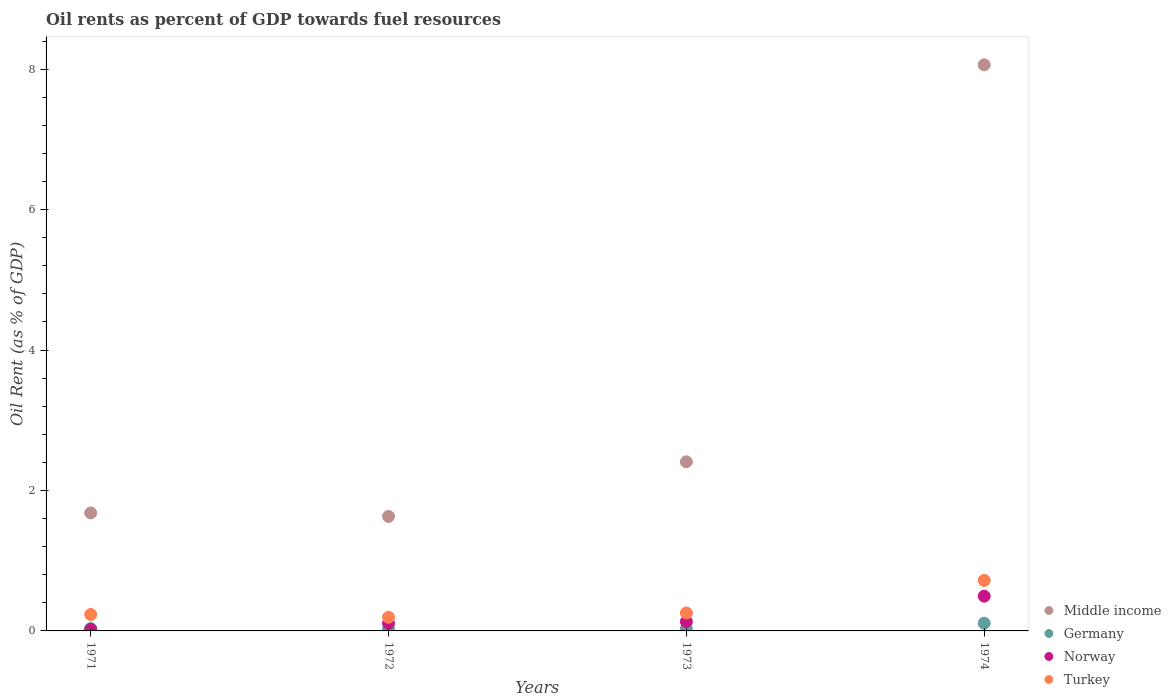What is the oil rent in Germany in 1972?
Offer a very short reply. 0.03. Across all years, what is the maximum oil rent in Germany?
Your answer should be compact. 0.11. Across all years, what is the minimum oil rent in Germany?
Your answer should be compact. 0.03. In which year was the oil rent in Germany maximum?
Give a very brief answer. 1974. In which year was the oil rent in Middle income minimum?
Your response must be concise. 1972. What is the total oil rent in Middle income in the graph?
Ensure brevity in your answer.  13.78. What is the difference between the oil rent in Turkey in 1971 and that in 1974?
Keep it short and to the point. -0.48. What is the difference between the oil rent in Germany in 1973 and the oil rent in Middle income in 1971?
Your answer should be compact. -1.65. What is the average oil rent in Germany per year?
Provide a succinct answer. 0.05. In the year 1973, what is the difference between the oil rent in Norway and oil rent in Turkey?
Your response must be concise. -0.12. What is the ratio of the oil rent in Germany in 1971 to that in 1974?
Your answer should be very brief. 0.31. Is the oil rent in Germany in 1971 less than that in 1973?
Offer a terse response. No. Is the difference between the oil rent in Norway in 1971 and 1973 greater than the difference between the oil rent in Turkey in 1971 and 1973?
Your answer should be compact. No. What is the difference between the highest and the second highest oil rent in Norway?
Make the answer very short. 0.36. What is the difference between the highest and the lowest oil rent in Middle income?
Keep it short and to the point. 6.43. In how many years, is the oil rent in Middle income greater than the average oil rent in Middle income taken over all years?
Keep it short and to the point. 1. Is the sum of the oil rent in Norway in 1972 and 1974 greater than the maximum oil rent in Germany across all years?
Your response must be concise. Yes. Is it the case that in every year, the sum of the oil rent in Germany and oil rent in Norway  is greater than the sum of oil rent in Turkey and oil rent in Middle income?
Your answer should be compact. No. Is it the case that in every year, the sum of the oil rent in Turkey and oil rent in Norway  is greater than the oil rent in Middle income?
Your answer should be very brief. No. How many years are there in the graph?
Your answer should be very brief. 4. Where does the legend appear in the graph?
Offer a terse response. Bottom right. How are the legend labels stacked?
Your response must be concise. Vertical. What is the title of the graph?
Give a very brief answer. Oil rents as percent of GDP towards fuel resources. Does "St. Vincent and the Grenadines" appear as one of the legend labels in the graph?
Provide a short and direct response. No. What is the label or title of the X-axis?
Your answer should be compact. Years. What is the label or title of the Y-axis?
Provide a short and direct response. Oil Rent (as % of GDP). What is the Oil Rent (as % of GDP) in Middle income in 1971?
Give a very brief answer. 1.68. What is the Oil Rent (as % of GDP) in Germany in 1971?
Your response must be concise. 0.03. What is the Oil Rent (as % of GDP) in Norway in 1971?
Make the answer very short. 0.02. What is the Oil Rent (as % of GDP) of Turkey in 1971?
Give a very brief answer. 0.23. What is the Oil Rent (as % of GDP) of Middle income in 1972?
Provide a short and direct response. 1.63. What is the Oil Rent (as % of GDP) of Germany in 1972?
Offer a terse response. 0.03. What is the Oil Rent (as % of GDP) of Norway in 1972?
Your answer should be very brief. 0.11. What is the Oil Rent (as % of GDP) of Turkey in 1972?
Make the answer very short. 0.19. What is the Oil Rent (as % of GDP) in Middle income in 1973?
Your response must be concise. 2.41. What is the Oil Rent (as % of GDP) of Germany in 1973?
Your answer should be very brief. 0.03. What is the Oil Rent (as % of GDP) of Norway in 1973?
Keep it short and to the point. 0.13. What is the Oil Rent (as % of GDP) of Turkey in 1973?
Give a very brief answer. 0.26. What is the Oil Rent (as % of GDP) in Middle income in 1974?
Ensure brevity in your answer.  8.06. What is the Oil Rent (as % of GDP) in Germany in 1974?
Give a very brief answer. 0.11. What is the Oil Rent (as % of GDP) of Norway in 1974?
Your answer should be compact. 0.49. What is the Oil Rent (as % of GDP) in Turkey in 1974?
Ensure brevity in your answer.  0.72. Across all years, what is the maximum Oil Rent (as % of GDP) of Middle income?
Ensure brevity in your answer.  8.06. Across all years, what is the maximum Oil Rent (as % of GDP) in Germany?
Keep it short and to the point. 0.11. Across all years, what is the maximum Oil Rent (as % of GDP) of Norway?
Ensure brevity in your answer.  0.49. Across all years, what is the maximum Oil Rent (as % of GDP) in Turkey?
Your response must be concise. 0.72. Across all years, what is the minimum Oil Rent (as % of GDP) of Middle income?
Offer a very short reply. 1.63. Across all years, what is the minimum Oil Rent (as % of GDP) in Germany?
Keep it short and to the point. 0.03. Across all years, what is the minimum Oil Rent (as % of GDP) of Norway?
Your response must be concise. 0.02. Across all years, what is the minimum Oil Rent (as % of GDP) of Turkey?
Ensure brevity in your answer.  0.19. What is the total Oil Rent (as % of GDP) in Middle income in the graph?
Offer a terse response. 13.78. What is the total Oil Rent (as % of GDP) of Germany in the graph?
Your answer should be very brief. 0.2. What is the total Oil Rent (as % of GDP) of Norway in the graph?
Offer a terse response. 0.76. What is the total Oil Rent (as % of GDP) in Turkey in the graph?
Offer a terse response. 1.4. What is the difference between the Oil Rent (as % of GDP) in Middle income in 1971 and that in 1972?
Offer a very short reply. 0.05. What is the difference between the Oil Rent (as % of GDP) of Germany in 1971 and that in 1972?
Make the answer very short. 0.01. What is the difference between the Oil Rent (as % of GDP) in Norway in 1971 and that in 1972?
Ensure brevity in your answer.  -0.09. What is the difference between the Oil Rent (as % of GDP) of Turkey in 1971 and that in 1972?
Provide a short and direct response. 0.04. What is the difference between the Oil Rent (as % of GDP) in Middle income in 1971 and that in 1973?
Your answer should be compact. -0.73. What is the difference between the Oil Rent (as % of GDP) in Germany in 1971 and that in 1973?
Provide a short and direct response. 0. What is the difference between the Oil Rent (as % of GDP) of Norway in 1971 and that in 1973?
Provide a succinct answer. -0.11. What is the difference between the Oil Rent (as % of GDP) in Turkey in 1971 and that in 1973?
Give a very brief answer. -0.02. What is the difference between the Oil Rent (as % of GDP) in Middle income in 1971 and that in 1974?
Offer a very short reply. -6.38. What is the difference between the Oil Rent (as % of GDP) of Germany in 1971 and that in 1974?
Your answer should be compact. -0.08. What is the difference between the Oil Rent (as % of GDP) in Norway in 1971 and that in 1974?
Your answer should be compact. -0.47. What is the difference between the Oil Rent (as % of GDP) in Turkey in 1971 and that in 1974?
Provide a short and direct response. -0.48. What is the difference between the Oil Rent (as % of GDP) of Middle income in 1972 and that in 1973?
Provide a short and direct response. -0.78. What is the difference between the Oil Rent (as % of GDP) of Germany in 1972 and that in 1973?
Your answer should be very brief. -0. What is the difference between the Oil Rent (as % of GDP) of Norway in 1972 and that in 1973?
Your answer should be very brief. -0.02. What is the difference between the Oil Rent (as % of GDP) in Turkey in 1972 and that in 1973?
Offer a terse response. -0.06. What is the difference between the Oil Rent (as % of GDP) in Middle income in 1972 and that in 1974?
Your answer should be compact. -6.43. What is the difference between the Oil Rent (as % of GDP) of Germany in 1972 and that in 1974?
Keep it short and to the point. -0.08. What is the difference between the Oil Rent (as % of GDP) of Norway in 1972 and that in 1974?
Give a very brief answer. -0.39. What is the difference between the Oil Rent (as % of GDP) in Turkey in 1972 and that in 1974?
Give a very brief answer. -0.53. What is the difference between the Oil Rent (as % of GDP) in Middle income in 1973 and that in 1974?
Make the answer very short. -5.65. What is the difference between the Oil Rent (as % of GDP) in Germany in 1973 and that in 1974?
Keep it short and to the point. -0.08. What is the difference between the Oil Rent (as % of GDP) in Norway in 1973 and that in 1974?
Provide a short and direct response. -0.36. What is the difference between the Oil Rent (as % of GDP) of Turkey in 1973 and that in 1974?
Keep it short and to the point. -0.46. What is the difference between the Oil Rent (as % of GDP) of Middle income in 1971 and the Oil Rent (as % of GDP) of Germany in 1972?
Offer a terse response. 1.65. What is the difference between the Oil Rent (as % of GDP) of Middle income in 1971 and the Oil Rent (as % of GDP) of Norway in 1972?
Provide a succinct answer. 1.57. What is the difference between the Oil Rent (as % of GDP) of Middle income in 1971 and the Oil Rent (as % of GDP) of Turkey in 1972?
Give a very brief answer. 1.49. What is the difference between the Oil Rent (as % of GDP) in Germany in 1971 and the Oil Rent (as % of GDP) in Norway in 1972?
Your answer should be compact. -0.07. What is the difference between the Oil Rent (as % of GDP) of Germany in 1971 and the Oil Rent (as % of GDP) of Turkey in 1972?
Provide a succinct answer. -0.16. What is the difference between the Oil Rent (as % of GDP) of Norway in 1971 and the Oil Rent (as % of GDP) of Turkey in 1972?
Provide a short and direct response. -0.17. What is the difference between the Oil Rent (as % of GDP) of Middle income in 1971 and the Oil Rent (as % of GDP) of Germany in 1973?
Offer a very short reply. 1.65. What is the difference between the Oil Rent (as % of GDP) of Middle income in 1971 and the Oil Rent (as % of GDP) of Norway in 1973?
Your response must be concise. 1.55. What is the difference between the Oil Rent (as % of GDP) in Middle income in 1971 and the Oil Rent (as % of GDP) in Turkey in 1973?
Offer a very short reply. 1.43. What is the difference between the Oil Rent (as % of GDP) of Germany in 1971 and the Oil Rent (as % of GDP) of Norway in 1973?
Offer a very short reply. -0.1. What is the difference between the Oil Rent (as % of GDP) of Germany in 1971 and the Oil Rent (as % of GDP) of Turkey in 1973?
Offer a terse response. -0.22. What is the difference between the Oil Rent (as % of GDP) in Norway in 1971 and the Oil Rent (as % of GDP) in Turkey in 1973?
Give a very brief answer. -0.23. What is the difference between the Oil Rent (as % of GDP) in Middle income in 1971 and the Oil Rent (as % of GDP) in Germany in 1974?
Provide a short and direct response. 1.57. What is the difference between the Oil Rent (as % of GDP) of Middle income in 1971 and the Oil Rent (as % of GDP) of Norway in 1974?
Keep it short and to the point. 1.19. What is the difference between the Oil Rent (as % of GDP) of Middle income in 1971 and the Oil Rent (as % of GDP) of Turkey in 1974?
Ensure brevity in your answer.  0.96. What is the difference between the Oil Rent (as % of GDP) of Germany in 1971 and the Oil Rent (as % of GDP) of Norway in 1974?
Ensure brevity in your answer.  -0.46. What is the difference between the Oil Rent (as % of GDP) of Germany in 1971 and the Oil Rent (as % of GDP) of Turkey in 1974?
Your answer should be compact. -0.69. What is the difference between the Oil Rent (as % of GDP) in Norway in 1971 and the Oil Rent (as % of GDP) in Turkey in 1974?
Keep it short and to the point. -0.7. What is the difference between the Oil Rent (as % of GDP) of Middle income in 1972 and the Oil Rent (as % of GDP) of Germany in 1973?
Your answer should be compact. 1.6. What is the difference between the Oil Rent (as % of GDP) of Middle income in 1972 and the Oil Rent (as % of GDP) of Norway in 1973?
Your answer should be very brief. 1.5. What is the difference between the Oil Rent (as % of GDP) in Middle income in 1972 and the Oil Rent (as % of GDP) in Turkey in 1973?
Make the answer very short. 1.38. What is the difference between the Oil Rent (as % of GDP) in Germany in 1972 and the Oil Rent (as % of GDP) in Norway in 1973?
Give a very brief answer. -0.1. What is the difference between the Oil Rent (as % of GDP) of Germany in 1972 and the Oil Rent (as % of GDP) of Turkey in 1973?
Give a very brief answer. -0.23. What is the difference between the Oil Rent (as % of GDP) of Norway in 1972 and the Oil Rent (as % of GDP) of Turkey in 1973?
Offer a terse response. -0.15. What is the difference between the Oil Rent (as % of GDP) of Middle income in 1972 and the Oil Rent (as % of GDP) of Germany in 1974?
Ensure brevity in your answer.  1.52. What is the difference between the Oil Rent (as % of GDP) in Middle income in 1972 and the Oil Rent (as % of GDP) in Norway in 1974?
Your answer should be compact. 1.14. What is the difference between the Oil Rent (as % of GDP) of Middle income in 1972 and the Oil Rent (as % of GDP) of Turkey in 1974?
Provide a short and direct response. 0.91. What is the difference between the Oil Rent (as % of GDP) in Germany in 1972 and the Oil Rent (as % of GDP) in Norway in 1974?
Your response must be concise. -0.47. What is the difference between the Oil Rent (as % of GDP) of Germany in 1972 and the Oil Rent (as % of GDP) of Turkey in 1974?
Offer a terse response. -0.69. What is the difference between the Oil Rent (as % of GDP) in Norway in 1972 and the Oil Rent (as % of GDP) in Turkey in 1974?
Provide a short and direct response. -0.61. What is the difference between the Oil Rent (as % of GDP) in Middle income in 1973 and the Oil Rent (as % of GDP) in Germany in 1974?
Give a very brief answer. 2.3. What is the difference between the Oil Rent (as % of GDP) of Middle income in 1973 and the Oil Rent (as % of GDP) of Norway in 1974?
Give a very brief answer. 1.91. What is the difference between the Oil Rent (as % of GDP) in Middle income in 1973 and the Oil Rent (as % of GDP) in Turkey in 1974?
Provide a succinct answer. 1.69. What is the difference between the Oil Rent (as % of GDP) in Germany in 1973 and the Oil Rent (as % of GDP) in Norway in 1974?
Keep it short and to the point. -0.46. What is the difference between the Oil Rent (as % of GDP) in Germany in 1973 and the Oil Rent (as % of GDP) in Turkey in 1974?
Keep it short and to the point. -0.69. What is the difference between the Oil Rent (as % of GDP) in Norway in 1973 and the Oil Rent (as % of GDP) in Turkey in 1974?
Your answer should be compact. -0.59. What is the average Oil Rent (as % of GDP) of Middle income per year?
Provide a succinct answer. 3.45. What is the average Oil Rent (as % of GDP) of Germany per year?
Provide a short and direct response. 0.05. What is the average Oil Rent (as % of GDP) in Norway per year?
Offer a terse response. 0.19. What is the average Oil Rent (as % of GDP) of Turkey per year?
Ensure brevity in your answer.  0.35. In the year 1971, what is the difference between the Oil Rent (as % of GDP) in Middle income and Oil Rent (as % of GDP) in Germany?
Provide a succinct answer. 1.65. In the year 1971, what is the difference between the Oil Rent (as % of GDP) of Middle income and Oil Rent (as % of GDP) of Norway?
Your answer should be very brief. 1.66. In the year 1971, what is the difference between the Oil Rent (as % of GDP) in Middle income and Oil Rent (as % of GDP) in Turkey?
Offer a terse response. 1.45. In the year 1971, what is the difference between the Oil Rent (as % of GDP) of Germany and Oil Rent (as % of GDP) of Norway?
Offer a terse response. 0.01. In the year 1971, what is the difference between the Oil Rent (as % of GDP) of Germany and Oil Rent (as % of GDP) of Turkey?
Your answer should be compact. -0.2. In the year 1971, what is the difference between the Oil Rent (as % of GDP) of Norway and Oil Rent (as % of GDP) of Turkey?
Provide a succinct answer. -0.21. In the year 1972, what is the difference between the Oil Rent (as % of GDP) of Middle income and Oil Rent (as % of GDP) of Germany?
Offer a very short reply. 1.6. In the year 1972, what is the difference between the Oil Rent (as % of GDP) in Middle income and Oil Rent (as % of GDP) in Norway?
Your answer should be compact. 1.52. In the year 1972, what is the difference between the Oil Rent (as % of GDP) of Middle income and Oil Rent (as % of GDP) of Turkey?
Keep it short and to the point. 1.44. In the year 1972, what is the difference between the Oil Rent (as % of GDP) of Germany and Oil Rent (as % of GDP) of Norway?
Ensure brevity in your answer.  -0.08. In the year 1972, what is the difference between the Oil Rent (as % of GDP) of Germany and Oil Rent (as % of GDP) of Turkey?
Your answer should be compact. -0.17. In the year 1972, what is the difference between the Oil Rent (as % of GDP) of Norway and Oil Rent (as % of GDP) of Turkey?
Give a very brief answer. -0.09. In the year 1973, what is the difference between the Oil Rent (as % of GDP) of Middle income and Oil Rent (as % of GDP) of Germany?
Ensure brevity in your answer.  2.38. In the year 1973, what is the difference between the Oil Rent (as % of GDP) in Middle income and Oil Rent (as % of GDP) in Norway?
Provide a short and direct response. 2.28. In the year 1973, what is the difference between the Oil Rent (as % of GDP) of Middle income and Oil Rent (as % of GDP) of Turkey?
Provide a short and direct response. 2.15. In the year 1973, what is the difference between the Oil Rent (as % of GDP) of Germany and Oil Rent (as % of GDP) of Norway?
Provide a short and direct response. -0.1. In the year 1973, what is the difference between the Oil Rent (as % of GDP) of Germany and Oil Rent (as % of GDP) of Turkey?
Provide a succinct answer. -0.22. In the year 1973, what is the difference between the Oil Rent (as % of GDP) in Norway and Oil Rent (as % of GDP) in Turkey?
Offer a very short reply. -0.12. In the year 1974, what is the difference between the Oil Rent (as % of GDP) of Middle income and Oil Rent (as % of GDP) of Germany?
Your answer should be very brief. 7.95. In the year 1974, what is the difference between the Oil Rent (as % of GDP) in Middle income and Oil Rent (as % of GDP) in Norway?
Make the answer very short. 7.57. In the year 1974, what is the difference between the Oil Rent (as % of GDP) in Middle income and Oil Rent (as % of GDP) in Turkey?
Your answer should be very brief. 7.34. In the year 1974, what is the difference between the Oil Rent (as % of GDP) in Germany and Oil Rent (as % of GDP) in Norway?
Make the answer very short. -0.39. In the year 1974, what is the difference between the Oil Rent (as % of GDP) in Germany and Oil Rent (as % of GDP) in Turkey?
Your answer should be very brief. -0.61. In the year 1974, what is the difference between the Oil Rent (as % of GDP) of Norway and Oil Rent (as % of GDP) of Turkey?
Offer a very short reply. -0.22. What is the ratio of the Oil Rent (as % of GDP) in Middle income in 1971 to that in 1972?
Provide a succinct answer. 1.03. What is the ratio of the Oil Rent (as % of GDP) in Germany in 1971 to that in 1972?
Ensure brevity in your answer.  1.19. What is the ratio of the Oil Rent (as % of GDP) of Norway in 1971 to that in 1972?
Provide a short and direct response. 0.2. What is the ratio of the Oil Rent (as % of GDP) in Turkey in 1971 to that in 1972?
Offer a terse response. 1.21. What is the ratio of the Oil Rent (as % of GDP) of Middle income in 1971 to that in 1973?
Make the answer very short. 0.7. What is the ratio of the Oil Rent (as % of GDP) of Germany in 1971 to that in 1973?
Your answer should be very brief. 1.06. What is the ratio of the Oil Rent (as % of GDP) of Norway in 1971 to that in 1973?
Provide a short and direct response. 0.17. What is the ratio of the Oil Rent (as % of GDP) in Turkey in 1971 to that in 1973?
Your answer should be very brief. 0.92. What is the ratio of the Oil Rent (as % of GDP) in Middle income in 1971 to that in 1974?
Provide a short and direct response. 0.21. What is the ratio of the Oil Rent (as % of GDP) in Germany in 1971 to that in 1974?
Offer a very short reply. 0.31. What is the ratio of the Oil Rent (as % of GDP) of Norway in 1971 to that in 1974?
Your answer should be compact. 0.04. What is the ratio of the Oil Rent (as % of GDP) in Turkey in 1971 to that in 1974?
Provide a short and direct response. 0.33. What is the ratio of the Oil Rent (as % of GDP) of Middle income in 1972 to that in 1973?
Ensure brevity in your answer.  0.68. What is the ratio of the Oil Rent (as % of GDP) of Germany in 1972 to that in 1973?
Your answer should be compact. 0.89. What is the ratio of the Oil Rent (as % of GDP) of Norway in 1972 to that in 1973?
Make the answer very short. 0.82. What is the ratio of the Oil Rent (as % of GDP) of Turkey in 1972 to that in 1973?
Keep it short and to the point. 0.76. What is the ratio of the Oil Rent (as % of GDP) of Middle income in 1972 to that in 1974?
Provide a succinct answer. 0.2. What is the ratio of the Oil Rent (as % of GDP) of Germany in 1972 to that in 1974?
Make the answer very short. 0.26. What is the ratio of the Oil Rent (as % of GDP) of Norway in 1972 to that in 1974?
Provide a short and direct response. 0.22. What is the ratio of the Oil Rent (as % of GDP) in Turkey in 1972 to that in 1974?
Your answer should be compact. 0.27. What is the ratio of the Oil Rent (as % of GDP) of Middle income in 1973 to that in 1974?
Offer a terse response. 0.3. What is the ratio of the Oil Rent (as % of GDP) of Germany in 1973 to that in 1974?
Ensure brevity in your answer.  0.29. What is the ratio of the Oil Rent (as % of GDP) in Norway in 1973 to that in 1974?
Your response must be concise. 0.27. What is the ratio of the Oil Rent (as % of GDP) in Turkey in 1973 to that in 1974?
Offer a very short reply. 0.35. What is the difference between the highest and the second highest Oil Rent (as % of GDP) of Middle income?
Ensure brevity in your answer.  5.65. What is the difference between the highest and the second highest Oil Rent (as % of GDP) in Germany?
Your answer should be very brief. 0.08. What is the difference between the highest and the second highest Oil Rent (as % of GDP) in Norway?
Provide a succinct answer. 0.36. What is the difference between the highest and the second highest Oil Rent (as % of GDP) in Turkey?
Your answer should be compact. 0.46. What is the difference between the highest and the lowest Oil Rent (as % of GDP) of Middle income?
Make the answer very short. 6.43. What is the difference between the highest and the lowest Oil Rent (as % of GDP) of Germany?
Offer a terse response. 0.08. What is the difference between the highest and the lowest Oil Rent (as % of GDP) of Norway?
Offer a terse response. 0.47. What is the difference between the highest and the lowest Oil Rent (as % of GDP) in Turkey?
Keep it short and to the point. 0.53. 